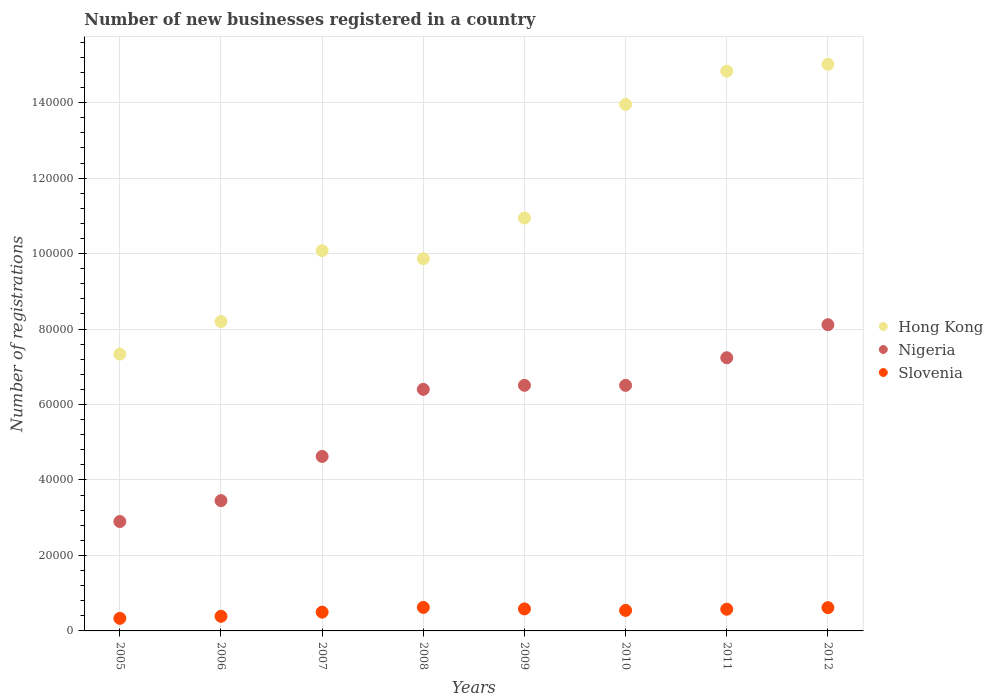What is the number of new businesses registered in Nigeria in 2010?
Your response must be concise. 6.51e+04. Across all years, what is the maximum number of new businesses registered in Hong Kong?
Your answer should be very brief. 1.50e+05. Across all years, what is the minimum number of new businesses registered in Slovenia?
Ensure brevity in your answer.  3334. In which year was the number of new businesses registered in Hong Kong minimum?
Keep it short and to the point. 2005. What is the total number of new businesses registered in Slovenia in the graph?
Make the answer very short. 4.16e+04. What is the difference between the number of new businesses registered in Hong Kong in 2006 and that in 2012?
Make the answer very short. -6.82e+04. What is the difference between the number of new businesses registered in Slovenia in 2010 and the number of new businesses registered in Nigeria in 2009?
Provide a succinct answer. -5.97e+04. What is the average number of new businesses registered in Nigeria per year?
Your answer should be very brief. 5.72e+04. In the year 2008, what is the difference between the number of new businesses registered in Hong Kong and number of new businesses registered in Nigeria?
Provide a short and direct response. 3.46e+04. What is the ratio of the number of new businesses registered in Hong Kong in 2010 to that in 2012?
Ensure brevity in your answer.  0.93. Is the number of new businesses registered in Slovenia in 2008 less than that in 2012?
Provide a short and direct response. No. What is the difference between the highest and the second highest number of new businesses registered in Nigeria?
Provide a succinct answer. 8748. What is the difference between the highest and the lowest number of new businesses registered in Nigeria?
Your response must be concise. 5.22e+04. Is it the case that in every year, the sum of the number of new businesses registered in Slovenia and number of new businesses registered in Hong Kong  is greater than the number of new businesses registered in Nigeria?
Ensure brevity in your answer.  Yes. Is the number of new businesses registered in Hong Kong strictly less than the number of new businesses registered in Slovenia over the years?
Ensure brevity in your answer.  No. How many dotlines are there?
Provide a succinct answer. 3. How many years are there in the graph?
Provide a succinct answer. 8. What is the difference between two consecutive major ticks on the Y-axis?
Your answer should be compact. 2.00e+04. Does the graph contain grids?
Your answer should be very brief. Yes. How many legend labels are there?
Provide a short and direct response. 3. What is the title of the graph?
Make the answer very short. Number of new businesses registered in a country. Does "Iceland" appear as one of the legend labels in the graph?
Make the answer very short. No. What is the label or title of the Y-axis?
Offer a terse response. Number of registrations. What is the Number of registrations of Hong Kong in 2005?
Offer a very short reply. 7.34e+04. What is the Number of registrations in Nigeria in 2005?
Provide a succinct answer. 2.90e+04. What is the Number of registrations of Slovenia in 2005?
Give a very brief answer. 3334. What is the Number of registrations in Hong Kong in 2006?
Your answer should be very brief. 8.20e+04. What is the Number of registrations of Nigeria in 2006?
Provide a succinct answer. 3.45e+04. What is the Number of registrations in Slovenia in 2006?
Give a very brief answer. 3869. What is the Number of registrations of Hong Kong in 2007?
Your answer should be compact. 1.01e+05. What is the Number of registrations in Nigeria in 2007?
Ensure brevity in your answer.  4.62e+04. What is the Number of registrations of Slovenia in 2007?
Give a very brief answer. 4976. What is the Number of registrations in Hong Kong in 2008?
Your answer should be very brief. 9.86e+04. What is the Number of registrations of Nigeria in 2008?
Your answer should be compact. 6.40e+04. What is the Number of registrations in Slovenia in 2008?
Make the answer very short. 6235. What is the Number of registrations in Hong Kong in 2009?
Keep it short and to the point. 1.09e+05. What is the Number of registrations of Nigeria in 2009?
Offer a very short reply. 6.51e+04. What is the Number of registrations in Slovenia in 2009?
Provide a succinct answer. 5836. What is the Number of registrations of Hong Kong in 2010?
Your answer should be very brief. 1.40e+05. What is the Number of registrations of Nigeria in 2010?
Your answer should be very brief. 6.51e+04. What is the Number of registrations in Slovenia in 2010?
Offer a very short reply. 5438. What is the Number of registrations in Hong Kong in 2011?
Provide a short and direct response. 1.48e+05. What is the Number of registrations of Nigeria in 2011?
Offer a terse response. 7.24e+04. What is the Number of registrations of Slovenia in 2011?
Keep it short and to the point. 5754. What is the Number of registrations in Hong Kong in 2012?
Offer a terse response. 1.50e+05. What is the Number of registrations of Nigeria in 2012?
Make the answer very short. 8.11e+04. What is the Number of registrations in Slovenia in 2012?
Give a very brief answer. 6174. Across all years, what is the maximum Number of registrations of Hong Kong?
Ensure brevity in your answer.  1.50e+05. Across all years, what is the maximum Number of registrations of Nigeria?
Give a very brief answer. 8.11e+04. Across all years, what is the maximum Number of registrations of Slovenia?
Offer a very short reply. 6235. Across all years, what is the minimum Number of registrations of Hong Kong?
Offer a terse response. 7.34e+04. Across all years, what is the minimum Number of registrations in Nigeria?
Your answer should be compact. 2.90e+04. Across all years, what is the minimum Number of registrations in Slovenia?
Your answer should be compact. 3334. What is the total Number of registrations in Hong Kong in the graph?
Give a very brief answer. 9.02e+05. What is the total Number of registrations of Nigeria in the graph?
Provide a short and direct response. 4.57e+05. What is the total Number of registrations of Slovenia in the graph?
Your answer should be compact. 4.16e+04. What is the difference between the Number of registrations in Hong Kong in 2005 and that in 2006?
Offer a very short reply. -8615. What is the difference between the Number of registrations in Nigeria in 2005 and that in 2006?
Provide a short and direct response. -5543. What is the difference between the Number of registrations in Slovenia in 2005 and that in 2006?
Your answer should be compact. -535. What is the difference between the Number of registrations of Hong Kong in 2005 and that in 2007?
Give a very brief answer. -2.74e+04. What is the difference between the Number of registrations of Nigeria in 2005 and that in 2007?
Keep it short and to the point. -1.73e+04. What is the difference between the Number of registrations in Slovenia in 2005 and that in 2007?
Your answer should be compact. -1642. What is the difference between the Number of registrations of Hong Kong in 2005 and that in 2008?
Ensure brevity in your answer.  -2.53e+04. What is the difference between the Number of registrations of Nigeria in 2005 and that in 2008?
Your response must be concise. -3.50e+04. What is the difference between the Number of registrations in Slovenia in 2005 and that in 2008?
Ensure brevity in your answer.  -2901. What is the difference between the Number of registrations of Hong Kong in 2005 and that in 2009?
Give a very brief answer. -3.61e+04. What is the difference between the Number of registrations of Nigeria in 2005 and that in 2009?
Offer a very short reply. -3.61e+04. What is the difference between the Number of registrations of Slovenia in 2005 and that in 2009?
Provide a short and direct response. -2502. What is the difference between the Number of registrations in Hong Kong in 2005 and that in 2010?
Offer a very short reply. -6.62e+04. What is the difference between the Number of registrations of Nigeria in 2005 and that in 2010?
Ensure brevity in your answer.  -3.61e+04. What is the difference between the Number of registrations of Slovenia in 2005 and that in 2010?
Make the answer very short. -2104. What is the difference between the Number of registrations in Hong Kong in 2005 and that in 2011?
Your response must be concise. -7.50e+04. What is the difference between the Number of registrations in Nigeria in 2005 and that in 2011?
Make the answer very short. -4.34e+04. What is the difference between the Number of registrations in Slovenia in 2005 and that in 2011?
Your answer should be compact. -2420. What is the difference between the Number of registrations of Hong Kong in 2005 and that in 2012?
Keep it short and to the point. -7.68e+04. What is the difference between the Number of registrations in Nigeria in 2005 and that in 2012?
Make the answer very short. -5.22e+04. What is the difference between the Number of registrations of Slovenia in 2005 and that in 2012?
Your answer should be very brief. -2840. What is the difference between the Number of registrations in Hong Kong in 2006 and that in 2007?
Offer a very short reply. -1.88e+04. What is the difference between the Number of registrations in Nigeria in 2006 and that in 2007?
Your response must be concise. -1.17e+04. What is the difference between the Number of registrations of Slovenia in 2006 and that in 2007?
Ensure brevity in your answer.  -1107. What is the difference between the Number of registrations of Hong Kong in 2006 and that in 2008?
Your answer should be compact. -1.67e+04. What is the difference between the Number of registrations of Nigeria in 2006 and that in 2008?
Offer a terse response. -2.95e+04. What is the difference between the Number of registrations in Slovenia in 2006 and that in 2008?
Ensure brevity in your answer.  -2366. What is the difference between the Number of registrations in Hong Kong in 2006 and that in 2009?
Provide a succinct answer. -2.74e+04. What is the difference between the Number of registrations of Nigeria in 2006 and that in 2009?
Ensure brevity in your answer.  -3.06e+04. What is the difference between the Number of registrations in Slovenia in 2006 and that in 2009?
Offer a very short reply. -1967. What is the difference between the Number of registrations of Hong Kong in 2006 and that in 2010?
Ensure brevity in your answer.  -5.76e+04. What is the difference between the Number of registrations in Nigeria in 2006 and that in 2010?
Your answer should be very brief. -3.05e+04. What is the difference between the Number of registrations of Slovenia in 2006 and that in 2010?
Provide a short and direct response. -1569. What is the difference between the Number of registrations in Hong Kong in 2006 and that in 2011?
Offer a terse response. -6.64e+04. What is the difference between the Number of registrations in Nigeria in 2006 and that in 2011?
Make the answer very short. -3.79e+04. What is the difference between the Number of registrations in Slovenia in 2006 and that in 2011?
Offer a very short reply. -1885. What is the difference between the Number of registrations of Hong Kong in 2006 and that in 2012?
Provide a succinct answer. -6.82e+04. What is the difference between the Number of registrations of Nigeria in 2006 and that in 2012?
Keep it short and to the point. -4.66e+04. What is the difference between the Number of registrations of Slovenia in 2006 and that in 2012?
Your response must be concise. -2305. What is the difference between the Number of registrations in Hong Kong in 2007 and that in 2008?
Keep it short and to the point. 2116. What is the difference between the Number of registrations of Nigeria in 2007 and that in 2008?
Keep it short and to the point. -1.78e+04. What is the difference between the Number of registrations of Slovenia in 2007 and that in 2008?
Your answer should be very brief. -1259. What is the difference between the Number of registrations of Hong Kong in 2007 and that in 2009?
Provide a succinct answer. -8663. What is the difference between the Number of registrations in Nigeria in 2007 and that in 2009?
Provide a short and direct response. -1.88e+04. What is the difference between the Number of registrations of Slovenia in 2007 and that in 2009?
Your response must be concise. -860. What is the difference between the Number of registrations of Hong Kong in 2007 and that in 2010?
Give a very brief answer. -3.88e+04. What is the difference between the Number of registrations of Nigeria in 2007 and that in 2010?
Your answer should be compact. -1.88e+04. What is the difference between the Number of registrations of Slovenia in 2007 and that in 2010?
Offer a terse response. -462. What is the difference between the Number of registrations of Hong Kong in 2007 and that in 2011?
Offer a very short reply. -4.76e+04. What is the difference between the Number of registrations of Nigeria in 2007 and that in 2011?
Offer a very short reply. -2.62e+04. What is the difference between the Number of registrations in Slovenia in 2007 and that in 2011?
Offer a very short reply. -778. What is the difference between the Number of registrations of Hong Kong in 2007 and that in 2012?
Keep it short and to the point. -4.94e+04. What is the difference between the Number of registrations in Nigeria in 2007 and that in 2012?
Your answer should be very brief. -3.49e+04. What is the difference between the Number of registrations in Slovenia in 2007 and that in 2012?
Provide a short and direct response. -1198. What is the difference between the Number of registrations of Hong Kong in 2008 and that in 2009?
Your response must be concise. -1.08e+04. What is the difference between the Number of registrations of Nigeria in 2008 and that in 2009?
Ensure brevity in your answer.  -1072. What is the difference between the Number of registrations in Slovenia in 2008 and that in 2009?
Keep it short and to the point. 399. What is the difference between the Number of registrations of Hong Kong in 2008 and that in 2010?
Your answer should be very brief. -4.09e+04. What is the difference between the Number of registrations in Nigeria in 2008 and that in 2010?
Your answer should be compact. -1057. What is the difference between the Number of registrations of Slovenia in 2008 and that in 2010?
Offer a very short reply. 797. What is the difference between the Number of registrations of Hong Kong in 2008 and that in 2011?
Offer a terse response. -4.97e+04. What is the difference between the Number of registrations of Nigeria in 2008 and that in 2011?
Your answer should be compact. -8379. What is the difference between the Number of registrations of Slovenia in 2008 and that in 2011?
Ensure brevity in your answer.  481. What is the difference between the Number of registrations in Hong Kong in 2008 and that in 2012?
Your answer should be compact. -5.15e+04. What is the difference between the Number of registrations in Nigeria in 2008 and that in 2012?
Your response must be concise. -1.71e+04. What is the difference between the Number of registrations of Slovenia in 2008 and that in 2012?
Keep it short and to the point. 61. What is the difference between the Number of registrations in Hong Kong in 2009 and that in 2010?
Your response must be concise. -3.01e+04. What is the difference between the Number of registrations in Slovenia in 2009 and that in 2010?
Provide a short and direct response. 398. What is the difference between the Number of registrations in Hong Kong in 2009 and that in 2011?
Give a very brief answer. -3.89e+04. What is the difference between the Number of registrations of Nigeria in 2009 and that in 2011?
Ensure brevity in your answer.  -7307. What is the difference between the Number of registrations in Slovenia in 2009 and that in 2011?
Your response must be concise. 82. What is the difference between the Number of registrations of Hong Kong in 2009 and that in 2012?
Make the answer very short. -4.07e+04. What is the difference between the Number of registrations of Nigeria in 2009 and that in 2012?
Keep it short and to the point. -1.61e+04. What is the difference between the Number of registrations in Slovenia in 2009 and that in 2012?
Your answer should be very brief. -338. What is the difference between the Number of registrations in Hong Kong in 2010 and that in 2011?
Ensure brevity in your answer.  -8799. What is the difference between the Number of registrations of Nigeria in 2010 and that in 2011?
Keep it short and to the point. -7322. What is the difference between the Number of registrations in Slovenia in 2010 and that in 2011?
Offer a terse response. -316. What is the difference between the Number of registrations of Hong Kong in 2010 and that in 2012?
Make the answer very short. -1.06e+04. What is the difference between the Number of registrations of Nigeria in 2010 and that in 2012?
Ensure brevity in your answer.  -1.61e+04. What is the difference between the Number of registrations in Slovenia in 2010 and that in 2012?
Keep it short and to the point. -736. What is the difference between the Number of registrations of Hong Kong in 2011 and that in 2012?
Keep it short and to the point. -1836. What is the difference between the Number of registrations of Nigeria in 2011 and that in 2012?
Make the answer very short. -8748. What is the difference between the Number of registrations of Slovenia in 2011 and that in 2012?
Give a very brief answer. -420. What is the difference between the Number of registrations in Hong Kong in 2005 and the Number of registrations in Nigeria in 2006?
Ensure brevity in your answer.  3.88e+04. What is the difference between the Number of registrations of Hong Kong in 2005 and the Number of registrations of Slovenia in 2006?
Ensure brevity in your answer.  6.95e+04. What is the difference between the Number of registrations in Nigeria in 2005 and the Number of registrations in Slovenia in 2006?
Your response must be concise. 2.51e+04. What is the difference between the Number of registrations in Hong Kong in 2005 and the Number of registrations in Nigeria in 2007?
Give a very brief answer. 2.71e+04. What is the difference between the Number of registrations in Hong Kong in 2005 and the Number of registrations in Slovenia in 2007?
Your answer should be very brief. 6.84e+04. What is the difference between the Number of registrations in Nigeria in 2005 and the Number of registrations in Slovenia in 2007?
Your response must be concise. 2.40e+04. What is the difference between the Number of registrations in Hong Kong in 2005 and the Number of registrations in Nigeria in 2008?
Make the answer very short. 9342. What is the difference between the Number of registrations of Hong Kong in 2005 and the Number of registrations of Slovenia in 2008?
Ensure brevity in your answer.  6.71e+04. What is the difference between the Number of registrations of Nigeria in 2005 and the Number of registrations of Slovenia in 2008?
Your response must be concise. 2.28e+04. What is the difference between the Number of registrations in Hong Kong in 2005 and the Number of registrations in Nigeria in 2009?
Provide a succinct answer. 8270. What is the difference between the Number of registrations of Hong Kong in 2005 and the Number of registrations of Slovenia in 2009?
Your answer should be compact. 6.75e+04. What is the difference between the Number of registrations in Nigeria in 2005 and the Number of registrations in Slovenia in 2009?
Provide a succinct answer. 2.32e+04. What is the difference between the Number of registrations in Hong Kong in 2005 and the Number of registrations in Nigeria in 2010?
Provide a short and direct response. 8285. What is the difference between the Number of registrations of Hong Kong in 2005 and the Number of registrations of Slovenia in 2010?
Offer a very short reply. 6.79e+04. What is the difference between the Number of registrations in Nigeria in 2005 and the Number of registrations in Slovenia in 2010?
Provide a short and direct response. 2.36e+04. What is the difference between the Number of registrations of Hong Kong in 2005 and the Number of registrations of Nigeria in 2011?
Your answer should be compact. 963. What is the difference between the Number of registrations in Hong Kong in 2005 and the Number of registrations in Slovenia in 2011?
Ensure brevity in your answer.  6.76e+04. What is the difference between the Number of registrations in Nigeria in 2005 and the Number of registrations in Slovenia in 2011?
Provide a succinct answer. 2.32e+04. What is the difference between the Number of registrations of Hong Kong in 2005 and the Number of registrations of Nigeria in 2012?
Your response must be concise. -7785. What is the difference between the Number of registrations of Hong Kong in 2005 and the Number of registrations of Slovenia in 2012?
Your answer should be very brief. 6.72e+04. What is the difference between the Number of registrations in Nigeria in 2005 and the Number of registrations in Slovenia in 2012?
Provide a succinct answer. 2.28e+04. What is the difference between the Number of registrations of Hong Kong in 2006 and the Number of registrations of Nigeria in 2007?
Your answer should be compact. 3.57e+04. What is the difference between the Number of registrations in Hong Kong in 2006 and the Number of registrations in Slovenia in 2007?
Your response must be concise. 7.70e+04. What is the difference between the Number of registrations in Nigeria in 2006 and the Number of registrations in Slovenia in 2007?
Make the answer very short. 2.96e+04. What is the difference between the Number of registrations in Hong Kong in 2006 and the Number of registrations in Nigeria in 2008?
Your answer should be very brief. 1.80e+04. What is the difference between the Number of registrations in Hong Kong in 2006 and the Number of registrations in Slovenia in 2008?
Offer a terse response. 7.57e+04. What is the difference between the Number of registrations in Nigeria in 2006 and the Number of registrations in Slovenia in 2008?
Make the answer very short. 2.83e+04. What is the difference between the Number of registrations of Hong Kong in 2006 and the Number of registrations of Nigeria in 2009?
Keep it short and to the point. 1.69e+04. What is the difference between the Number of registrations in Hong Kong in 2006 and the Number of registrations in Slovenia in 2009?
Provide a short and direct response. 7.61e+04. What is the difference between the Number of registrations of Nigeria in 2006 and the Number of registrations of Slovenia in 2009?
Give a very brief answer. 2.87e+04. What is the difference between the Number of registrations in Hong Kong in 2006 and the Number of registrations in Nigeria in 2010?
Provide a short and direct response. 1.69e+04. What is the difference between the Number of registrations of Hong Kong in 2006 and the Number of registrations of Slovenia in 2010?
Make the answer very short. 7.65e+04. What is the difference between the Number of registrations of Nigeria in 2006 and the Number of registrations of Slovenia in 2010?
Give a very brief answer. 2.91e+04. What is the difference between the Number of registrations in Hong Kong in 2006 and the Number of registrations in Nigeria in 2011?
Offer a very short reply. 9578. What is the difference between the Number of registrations in Hong Kong in 2006 and the Number of registrations in Slovenia in 2011?
Provide a short and direct response. 7.62e+04. What is the difference between the Number of registrations in Nigeria in 2006 and the Number of registrations in Slovenia in 2011?
Offer a very short reply. 2.88e+04. What is the difference between the Number of registrations in Hong Kong in 2006 and the Number of registrations in Nigeria in 2012?
Give a very brief answer. 830. What is the difference between the Number of registrations of Hong Kong in 2006 and the Number of registrations of Slovenia in 2012?
Offer a very short reply. 7.58e+04. What is the difference between the Number of registrations in Nigeria in 2006 and the Number of registrations in Slovenia in 2012?
Offer a terse response. 2.84e+04. What is the difference between the Number of registrations in Hong Kong in 2007 and the Number of registrations in Nigeria in 2008?
Your answer should be very brief. 3.67e+04. What is the difference between the Number of registrations in Hong Kong in 2007 and the Number of registrations in Slovenia in 2008?
Give a very brief answer. 9.45e+04. What is the difference between the Number of registrations of Nigeria in 2007 and the Number of registrations of Slovenia in 2008?
Give a very brief answer. 4.00e+04. What is the difference between the Number of registrations of Hong Kong in 2007 and the Number of registrations of Nigeria in 2009?
Your answer should be very brief. 3.57e+04. What is the difference between the Number of registrations of Hong Kong in 2007 and the Number of registrations of Slovenia in 2009?
Offer a very short reply. 9.49e+04. What is the difference between the Number of registrations of Nigeria in 2007 and the Number of registrations of Slovenia in 2009?
Your answer should be very brief. 4.04e+04. What is the difference between the Number of registrations of Hong Kong in 2007 and the Number of registrations of Nigeria in 2010?
Keep it short and to the point. 3.57e+04. What is the difference between the Number of registrations in Hong Kong in 2007 and the Number of registrations in Slovenia in 2010?
Offer a terse response. 9.53e+04. What is the difference between the Number of registrations in Nigeria in 2007 and the Number of registrations in Slovenia in 2010?
Keep it short and to the point. 4.08e+04. What is the difference between the Number of registrations in Hong Kong in 2007 and the Number of registrations in Nigeria in 2011?
Your answer should be very brief. 2.84e+04. What is the difference between the Number of registrations in Hong Kong in 2007 and the Number of registrations in Slovenia in 2011?
Offer a terse response. 9.50e+04. What is the difference between the Number of registrations of Nigeria in 2007 and the Number of registrations of Slovenia in 2011?
Provide a succinct answer. 4.05e+04. What is the difference between the Number of registrations of Hong Kong in 2007 and the Number of registrations of Nigeria in 2012?
Offer a very short reply. 1.96e+04. What is the difference between the Number of registrations in Hong Kong in 2007 and the Number of registrations in Slovenia in 2012?
Ensure brevity in your answer.  9.46e+04. What is the difference between the Number of registrations of Nigeria in 2007 and the Number of registrations of Slovenia in 2012?
Ensure brevity in your answer.  4.01e+04. What is the difference between the Number of registrations of Hong Kong in 2008 and the Number of registrations of Nigeria in 2009?
Make the answer very short. 3.36e+04. What is the difference between the Number of registrations in Hong Kong in 2008 and the Number of registrations in Slovenia in 2009?
Provide a succinct answer. 9.28e+04. What is the difference between the Number of registrations of Nigeria in 2008 and the Number of registrations of Slovenia in 2009?
Give a very brief answer. 5.82e+04. What is the difference between the Number of registrations in Hong Kong in 2008 and the Number of registrations in Nigeria in 2010?
Ensure brevity in your answer.  3.36e+04. What is the difference between the Number of registrations of Hong Kong in 2008 and the Number of registrations of Slovenia in 2010?
Keep it short and to the point. 9.32e+04. What is the difference between the Number of registrations in Nigeria in 2008 and the Number of registrations in Slovenia in 2010?
Provide a short and direct response. 5.86e+04. What is the difference between the Number of registrations in Hong Kong in 2008 and the Number of registrations in Nigeria in 2011?
Keep it short and to the point. 2.62e+04. What is the difference between the Number of registrations of Hong Kong in 2008 and the Number of registrations of Slovenia in 2011?
Your answer should be very brief. 9.29e+04. What is the difference between the Number of registrations in Nigeria in 2008 and the Number of registrations in Slovenia in 2011?
Your response must be concise. 5.83e+04. What is the difference between the Number of registrations in Hong Kong in 2008 and the Number of registrations in Nigeria in 2012?
Your answer should be compact. 1.75e+04. What is the difference between the Number of registrations of Hong Kong in 2008 and the Number of registrations of Slovenia in 2012?
Your answer should be very brief. 9.25e+04. What is the difference between the Number of registrations in Nigeria in 2008 and the Number of registrations in Slovenia in 2012?
Your answer should be very brief. 5.78e+04. What is the difference between the Number of registrations of Hong Kong in 2009 and the Number of registrations of Nigeria in 2010?
Keep it short and to the point. 4.44e+04. What is the difference between the Number of registrations in Hong Kong in 2009 and the Number of registrations in Slovenia in 2010?
Your answer should be compact. 1.04e+05. What is the difference between the Number of registrations of Nigeria in 2009 and the Number of registrations of Slovenia in 2010?
Your answer should be compact. 5.97e+04. What is the difference between the Number of registrations in Hong Kong in 2009 and the Number of registrations in Nigeria in 2011?
Ensure brevity in your answer.  3.70e+04. What is the difference between the Number of registrations in Hong Kong in 2009 and the Number of registrations in Slovenia in 2011?
Keep it short and to the point. 1.04e+05. What is the difference between the Number of registrations in Nigeria in 2009 and the Number of registrations in Slovenia in 2011?
Your answer should be very brief. 5.93e+04. What is the difference between the Number of registrations in Hong Kong in 2009 and the Number of registrations in Nigeria in 2012?
Give a very brief answer. 2.83e+04. What is the difference between the Number of registrations of Hong Kong in 2009 and the Number of registrations of Slovenia in 2012?
Give a very brief answer. 1.03e+05. What is the difference between the Number of registrations of Nigeria in 2009 and the Number of registrations of Slovenia in 2012?
Provide a short and direct response. 5.89e+04. What is the difference between the Number of registrations of Hong Kong in 2010 and the Number of registrations of Nigeria in 2011?
Make the answer very short. 6.71e+04. What is the difference between the Number of registrations of Hong Kong in 2010 and the Number of registrations of Slovenia in 2011?
Your answer should be compact. 1.34e+05. What is the difference between the Number of registrations of Nigeria in 2010 and the Number of registrations of Slovenia in 2011?
Offer a very short reply. 5.93e+04. What is the difference between the Number of registrations of Hong Kong in 2010 and the Number of registrations of Nigeria in 2012?
Your answer should be very brief. 5.84e+04. What is the difference between the Number of registrations of Hong Kong in 2010 and the Number of registrations of Slovenia in 2012?
Your response must be concise. 1.33e+05. What is the difference between the Number of registrations of Nigeria in 2010 and the Number of registrations of Slovenia in 2012?
Keep it short and to the point. 5.89e+04. What is the difference between the Number of registrations of Hong Kong in 2011 and the Number of registrations of Nigeria in 2012?
Your response must be concise. 6.72e+04. What is the difference between the Number of registrations of Hong Kong in 2011 and the Number of registrations of Slovenia in 2012?
Keep it short and to the point. 1.42e+05. What is the difference between the Number of registrations of Nigeria in 2011 and the Number of registrations of Slovenia in 2012?
Keep it short and to the point. 6.62e+04. What is the average Number of registrations of Hong Kong per year?
Offer a very short reply. 1.13e+05. What is the average Number of registrations in Nigeria per year?
Offer a terse response. 5.72e+04. What is the average Number of registrations of Slovenia per year?
Provide a succinct answer. 5202. In the year 2005, what is the difference between the Number of registrations of Hong Kong and Number of registrations of Nigeria?
Your answer should be very brief. 4.44e+04. In the year 2005, what is the difference between the Number of registrations of Hong Kong and Number of registrations of Slovenia?
Your response must be concise. 7.00e+04. In the year 2005, what is the difference between the Number of registrations of Nigeria and Number of registrations of Slovenia?
Provide a short and direct response. 2.57e+04. In the year 2006, what is the difference between the Number of registrations in Hong Kong and Number of registrations in Nigeria?
Make the answer very short. 4.74e+04. In the year 2006, what is the difference between the Number of registrations in Hong Kong and Number of registrations in Slovenia?
Ensure brevity in your answer.  7.81e+04. In the year 2006, what is the difference between the Number of registrations in Nigeria and Number of registrations in Slovenia?
Provide a short and direct response. 3.07e+04. In the year 2007, what is the difference between the Number of registrations of Hong Kong and Number of registrations of Nigeria?
Provide a short and direct response. 5.45e+04. In the year 2007, what is the difference between the Number of registrations of Hong Kong and Number of registrations of Slovenia?
Your answer should be very brief. 9.58e+04. In the year 2007, what is the difference between the Number of registrations in Nigeria and Number of registrations in Slovenia?
Offer a very short reply. 4.13e+04. In the year 2008, what is the difference between the Number of registrations of Hong Kong and Number of registrations of Nigeria?
Make the answer very short. 3.46e+04. In the year 2008, what is the difference between the Number of registrations in Hong Kong and Number of registrations in Slovenia?
Make the answer very short. 9.24e+04. In the year 2008, what is the difference between the Number of registrations in Nigeria and Number of registrations in Slovenia?
Ensure brevity in your answer.  5.78e+04. In the year 2009, what is the difference between the Number of registrations of Hong Kong and Number of registrations of Nigeria?
Keep it short and to the point. 4.43e+04. In the year 2009, what is the difference between the Number of registrations in Hong Kong and Number of registrations in Slovenia?
Give a very brief answer. 1.04e+05. In the year 2009, what is the difference between the Number of registrations in Nigeria and Number of registrations in Slovenia?
Give a very brief answer. 5.93e+04. In the year 2010, what is the difference between the Number of registrations in Hong Kong and Number of registrations in Nigeria?
Ensure brevity in your answer.  7.45e+04. In the year 2010, what is the difference between the Number of registrations in Hong Kong and Number of registrations in Slovenia?
Ensure brevity in your answer.  1.34e+05. In the year 2010, what is the difference between the Number of registrations of Nigeria and Number of registrations of Slovenia?
Your answer should be very brief. 5.96e+04. In the year 2011, what is the difference between the Number of registrations of Hong Kong and Number of registrations of Nigeria?
Keep it short and to the point. 7.59e+04. In the year 2011, what is the difference between the Number of registrations of Hong Kong and Number of registrations of Slovenia?
Ensure brevity in your answer.  1.43e+05. In the year 2011, what is the difference between the Number of registrations in Nigeria and Number of registrations in Slovenia?
Provide a short and direct response. 6.66e+04. In the year 2012, what is the difference between the Number of registrations in Hong Kong and Number of registrations in Nigeria?
Keep it short and to the point. 6.90e+04. In the year 2012, what is the difference between the Number of registrations in Hong Kong and Number of registrations in Slovenia?
Ensure brevity in your answer.  1.44e+05. In the year 2012, what is the difference between the Number of registrations in Nigeria and Number of registrations in Slovenia?
Offer a terse response. 7.50e+04. What is the ratio of the Number of registrations of Hong Kong in 2005 to that in 2006?
Offer a very short reply. 0.89. What is the ratio of the Number of registrations in Nigeria in 2005 to that in 2006?
Provide a succinct answer. 0.84. What is the ratio of the Number of registrations of Slovenia in 2005 to that in 2006?
Give a very brief answer. 0.86. What is the ratio of the Number of registrations in Hong Kong in 2005 to that in 2007?
Provide a short and direct response. 0.73. What is the ratio of the Number of registrations in Nigeria in 2005 to that in 2007?
Provide a short and direct response. 0.63. What is the ratio of the Number of registrations in Slovenia in 2005 to that in 2007?
Provide a succinct answer. 0.67. What is the ratio of the Number of registrations of Hong Kong in 2005 to that in 2008?
Offer a terse response. 0.74. What is the ratio of the Number of registrations in Nigeria in 2005 to that in 2008?
Offer a terse response. 0.45. What is the ratio of the Number of registrations in Slovenia in 2005 to that in 2008?
Provide a short and direct response. 0.53. What is the ratio of the Number of registrations of Hong Kong in 2005 to that in 2009?
Your answer should be compact. 0.67. What is the ratio of the Number of registrations in Nigeria in 2005 to that in 2009?
Provide a short and direct response. 0.45. What is the ratio of the Number of registrations of Slovenia in 2005 to that in 2009?
Provide a short and direct response. 0.57. What is the ratio of the Number of registrations of Hong Kong in 2005 to that in 2010?
Make the answer very short. 0.53. What is the ratio of the Number of registrations of Nigeria in 2005 to that in 2010?
Your response must be concise. 0.45. What is the ratio of the Number of registrations of Slovenia in 2005 to that in 2010?
Ensure brevity in your answer.  0.61. What is the ratio of the Number of registrations in Hong Kong in 2005 to that in 2011?
Keep it short and to the point. 0.49. What is the ratio of the Number of registrations of Nigeria in 2005 to that in 2011?
Your answer should be compact. 0.4. What is the ratio of the Number of registrations of Slovenia in 2005 to that in 2011?
Ensure brevity in your answer.  0.58. What is the ratio of the Number of registrations in Hong Kong in 2005 to that in 2012?
Make the answer very short. 0.49. What is the ratio of the Number of registrations in Nigeria in 2005 to that in 2012?
Provide a succinct answer. 0.36. What is the ratio of the Number of registrations in Slovenia in 2005 to that in 2012?
Your answer should be very brief. 0.54. What is the ratio of the Number of registrations of Hong Kong in 2006 to that in 2007?
Provide a short and direct response. 0.81. What is the ratio of the Number of registrations in Nigeria in 2006 to that in 2007?
Provide a short and direct response. 0.75. What is the ratio of the Number of registrations in Slovenia in 2006 to that in 2007?
Offer a very short reply. 0.78. What is the ratio of the Number of registrations in Hong Kong in 2006 to that in 2008?
Provide a succinct answer. 0.83. What is the ratio of the Number of registrations of Nigeria in 2006 to that in 2008?
Offer a very short reply. 0.54. What is the ratio of the Number of registrations of Slovenia in 2006 to that in 2008?
Offer a very short reply. 0.62. What is the ratio of the Number of registrations of Hong Kong in 2006 to that in 2009?
Your response must be concise. 0.75. What is the ratio of the Number of registrations of Nigeria in 2006 to that in 2009?
Keep it short and to the point. 0.53. What is the ratio of the Number of registrations of Slovenia in 2006 to that in 2009?
Provide a succinct answer. 0.66. What is the ratio of the Number of registrations of Hong Kong in 2006 to that in 2010?
Offer a very short reply. 0.59. What is the ratio of the Number of registrations of Nigeria in 2006 to that in 2010?
Your answer should be compact. 0.53. What is the ratio of the Number of registrations in Slovenia in 2006 to that in 2010?
Your answer should be compact. 0.71. What is the ratio of the Number of registrations of Hong Kong in 2006 to that in 2011?
Provide a succinct answer. 0.55. What is the ratio of the Number of registrations in Nigeria in 2006 to that in 2011?
Offer a very short reply. 0.48. What is the ratio of the Number of registrations in Slovenia in 2006 to that in 2011?
Your answer should be compact. 0.67. What is the ratio of the Number of registrations in Hong Kong in 2006 to that in 2012?
Make the answer very short. 0.55. What is the ratio of the Number of registrations in Nigeria in 2006 to that in 2012?
Your answer should be very brief. 0.43. What is the ratio of the Number of registrations in Slovenia in 2006 to that in 2012?
Provide a succinct answer. 0.63. What is the ratio of the Number of registrations of Hong Kong in 2007 to that in 2008?
Make the answer very short. 1.02. What is the ratio of the Number of registrations of Nigeria in 2007 to that in 2008?
Give a very brief answer. 0.72. What is the ratio of the Number of registrations of Slovenia in 2007 to that in 2008?
Keep it short and to the point. 0.8. What is the ratio of the Number of registrations in Hong Kong in 2007 to that in 2009?
Your answer should be compact. 0.92. What is the ratio of the Number of registrations in Nigeria in 2007 to that in 2009?
Your answer should be compact. 0.71. What is the ratio of the Number of registrations in Slovenia in 2007 to that in 2009?
Your answer should be very brief. 0.85. What is the ratio of the Number of registrations of Hong Kong in 2007 to that in 2010?
Your answer should be very brief. 0.72. What is the ratio of the Number of registrations of Nigeria in 2007 to that in 2010?
Your response must be concise. 0.71. What is the ratio of the Number of registrations in Slovenia in 2007 to that in 2010?
Keep it short and to the point. 0.92. What is the ratio of the Number of registrations of Hong Kong in 2007 to that in 2011?
Make the answer very short. 0.68. What is the ratio of the Number of registrations of Nigeria in 2007 to that in 2011?
Offer a very short reply. 0.64. What is the ratio of the Number of registrations in Slovenia in 2007 to that in 2011?
Your answer should be very brief. 0.86. What is the ratio of the Number of registrations of Hong Kong in 2007 to that in 2012?
Your response must be concise. 0.67. What is the ratio of the Number of registrations in Nigeria in 2007 to that in 2012?
Offer a very short reply. 0.57. What is the ratio of the Number of registrations of Slovenia in 2007 to that in 2012?
Make the answer very short. 0.81. What is the ratio of the Number of registrations in Hong Kong in 2008 to that in 2009?
Offer a very short reply. 0.9. What is the ratio of the Number of registrations in Nigeria in 2008 to that in 2009?
Offer a very short reply. 0.98. What is the ratio of the Number of registrations of Slovenia in 2008 to that in 2009?
Make the answer very short. 1.07. What is the ratio of the Number of registrations of Hong Kong in 2008 to that in 2010?
Ensure brevity in your answer.  0.71. What is the ratio of the Number of registrations in Nigeria in 2008 to that in 2010?
Offer a very short reply. 0.98. What is the ratio of the Number of registrations of Slovenia in 2008 to that in 2010?
Your response must be concise. 1.15. What is the ratio of the Number of registrations of Hong Kong in 2008 to that in 2011?
Offer a terse response. 0.67. What is the ratio of the Number of registrations of Nigeria in 2008 to that in 2011?
Keep it short and to the point. 0.88. What is the ratio of the Number of registrations of Slovenia in 2008 to that in 2011?
Give a very brief answer. 1.08. What is the ratio of the Number of registrations in Hong Kong in 2008 to that in 2012?
Your response must be concise. 0.66. What is the ratio of the Number of registrations of Nigeria in 2008 to that in 2012?
Provide a short and direct response. 0.79. What is the ratio of the Number of registrations of Slovenia in 2008 to that in 2012?
Give a very brief answer. 1.01. What is the ratio of the Number of registrations of Hong Kong in 2009 to that in 2010?
Make the answer very short. 0.78. What is the ratio of the Number of registrations of Slovenia in 2009 to that in 2010?
Ensure brevity in your answer.  1.07. What is the ratio of the Number of registrations in Hong Kong in 2009 to that in 2011?
Keep it short and to the point. 0.74. What is the ratio of the Number of registrations in Nigeria in 2009 to that in 2011?
Make the answer very short. 0.9. What is the ratio of the Number of registrations of Slovenia in 2009 to that in 2011?
Give a very brief answer. 1.01. What is the ratio of the Number of registrations of Hong Kong in 2009 to that in 2012?
Provide a succinct answer. 0.73. What is the ratio of the Number of registrations of Nigeria in 2009 to that in 2012?
Make the answer very short. 0.8. What is the ratio of the Number of registrations of Slovenia in 2009 to that in 2012?
Your response must be concise. 0.95. What is the ratio of the Number of registrations of Hong Kong in 2010 to that in 2011?
Ensure brevity in your answer.  0.94. What is the ratio of the Number of registrations in Nigeria in 2010 to that in 2011?
Your answer should be very brief. 0.9. What is the ratio of the Number of registrations of Slovenia in 2010 to that in 2011?
Give a very brief answer. 0.95. What is the ratio of the Number of registrations of Hong Kong in 2010 to that in 2012?
Keep it short and to the point. 0.93. What is the ratio of the Number of registrations of Nigeria in 2010 to that in 2012?
Your response must be concise. 0.8. What is the ratio of the Number of registrations in Slovenia in 2010 to that in 2012?
Keep it short and to the point. 0.88. What is the ratio of the Number of registrations in Nigeria in 2011 to that in 2012?
Provide a succinct answer. 0.89. What is the ratio of the Number of registrations of Slovenia in 2011 to that in 2012?
Ensure brevity in your answer.  0.93. What is the difference between the highest and the second highest Number of registrations in Hong Kong?
Your answer should be compact. 1836. What is the difference between the highest and the second highest Number of registrations of Nigeria?
Your response must be concise. 8748. What is the difference between the highest and the lowest Number of registrations of Hong Kong?
Offer a terse response. 7.68e+04. What is the difference between the highest and the lowest Number of registrations of Nigeria?
Offer a terse response. 5.22e+04. What is the difference between the highest and the lowest Number of registrations in Slovenia?
Offer a very short reply. 2901. 